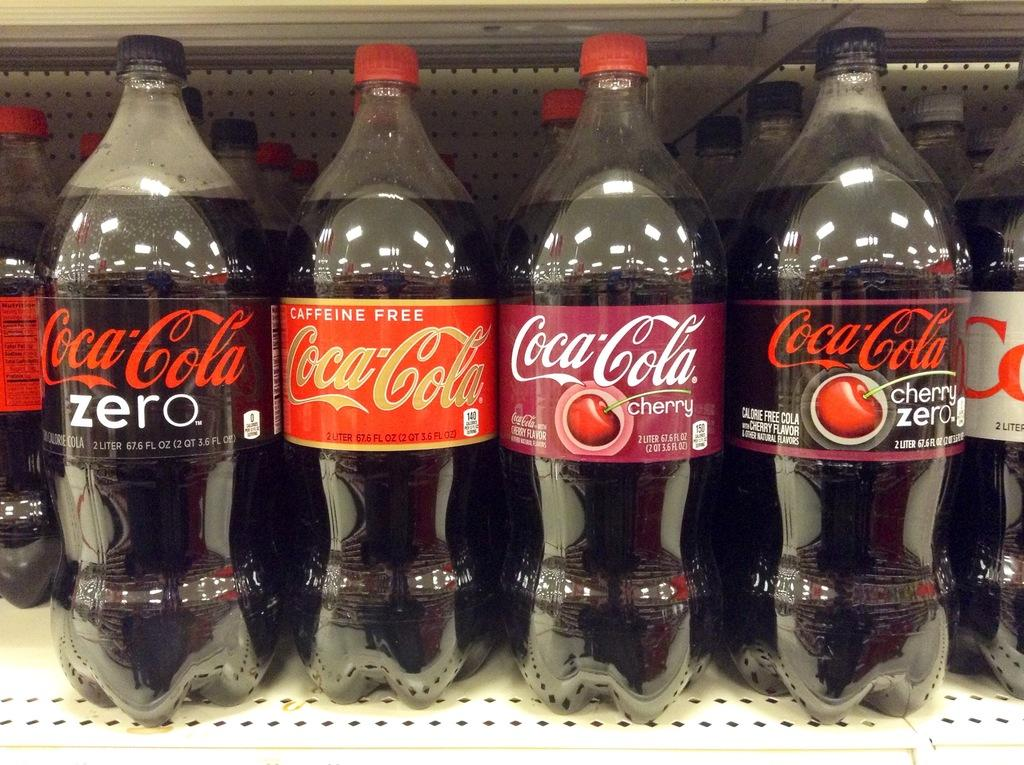What type of beverage is contained in the bottles in the image? The bottles in the image contain Coke. Can you describe the different types of Coke bottles in the image? The Coke bottles come in different varieties. What does the queen say about her brother in the image? There is no queen or brother present in the image; it only features Coke bottles. 